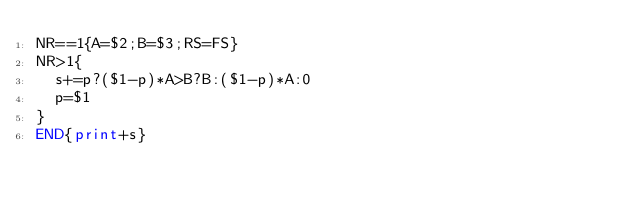Convert code to text. <code><loc_0><loc_0><loc_500><loc_500><_Awk_>NR==1{A=$2;B=$3;RS=FS}
NR>1{
	s+=p?($1-p)*A>B?B:($1-p)*A:0
	p=$1
}
END{print+s}</code> 